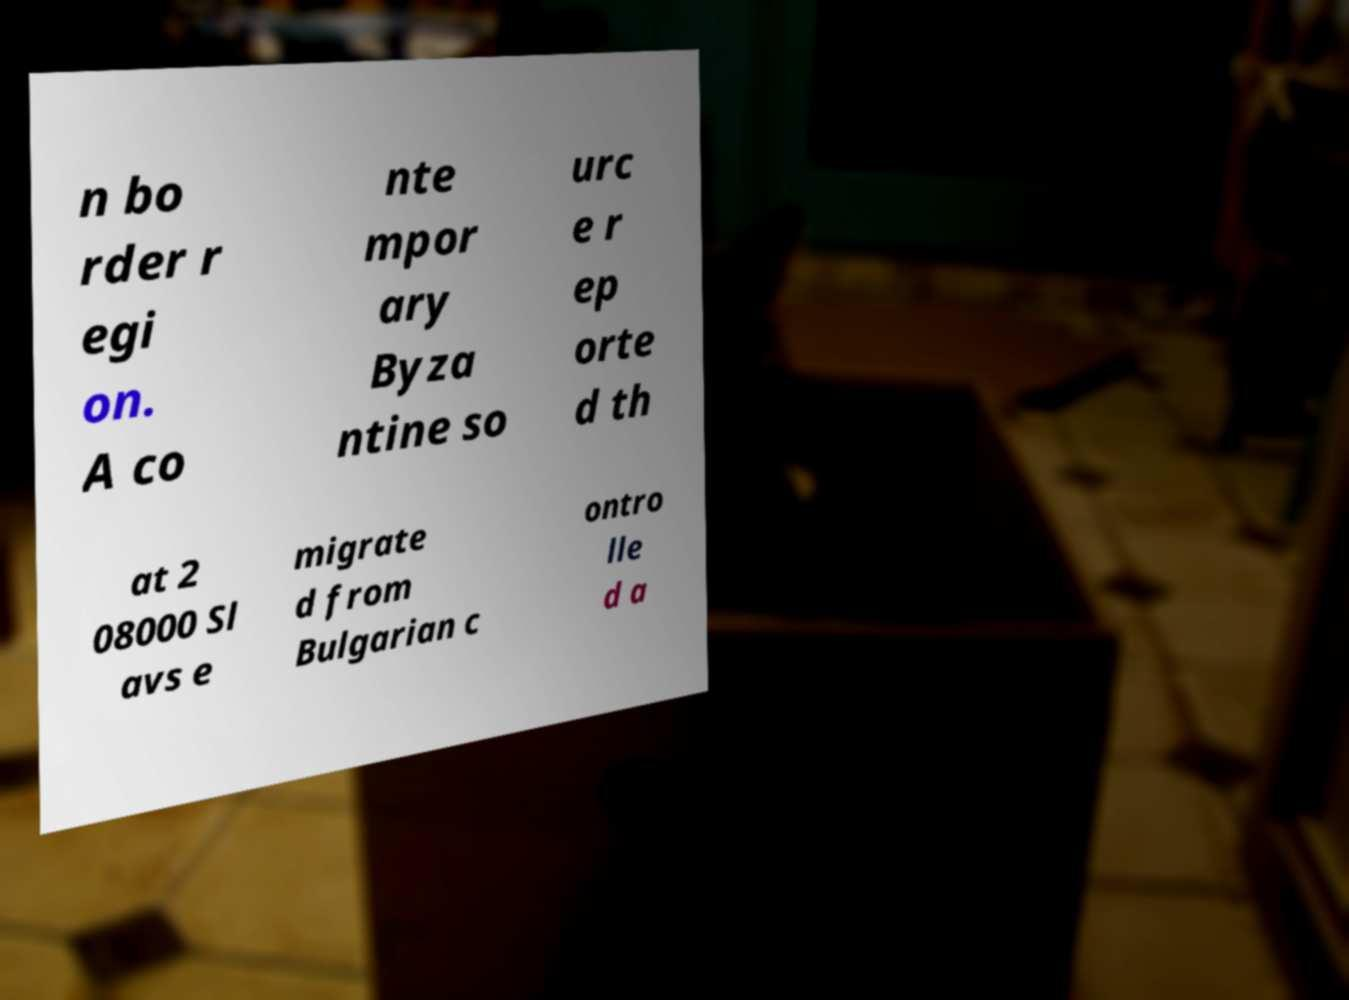Can you accurately transcribe the text from the provided image for me? n bo rder r egi on. A co nte mpor ary Byza ntine so urc e r ep orte d th at 2 08000 Sl avs e migrate d from Bulgarian c ontro lle d a 